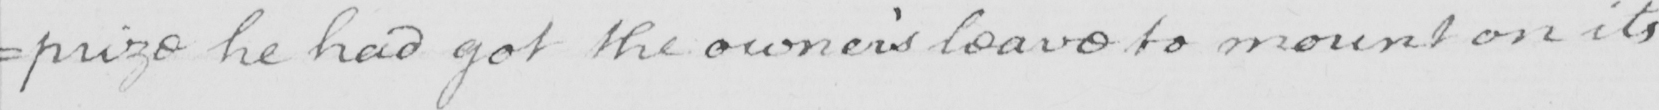What text is written in this handwritten line? =prize he had got the owner ' s leave to mount on its 